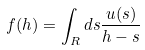Convert formula to latex. <formula><loc_0><loc_0><loc_500><loc_500>f ( h ) = \int _ { R } d s \frac { u ( s ) } { h - s }</formula> 